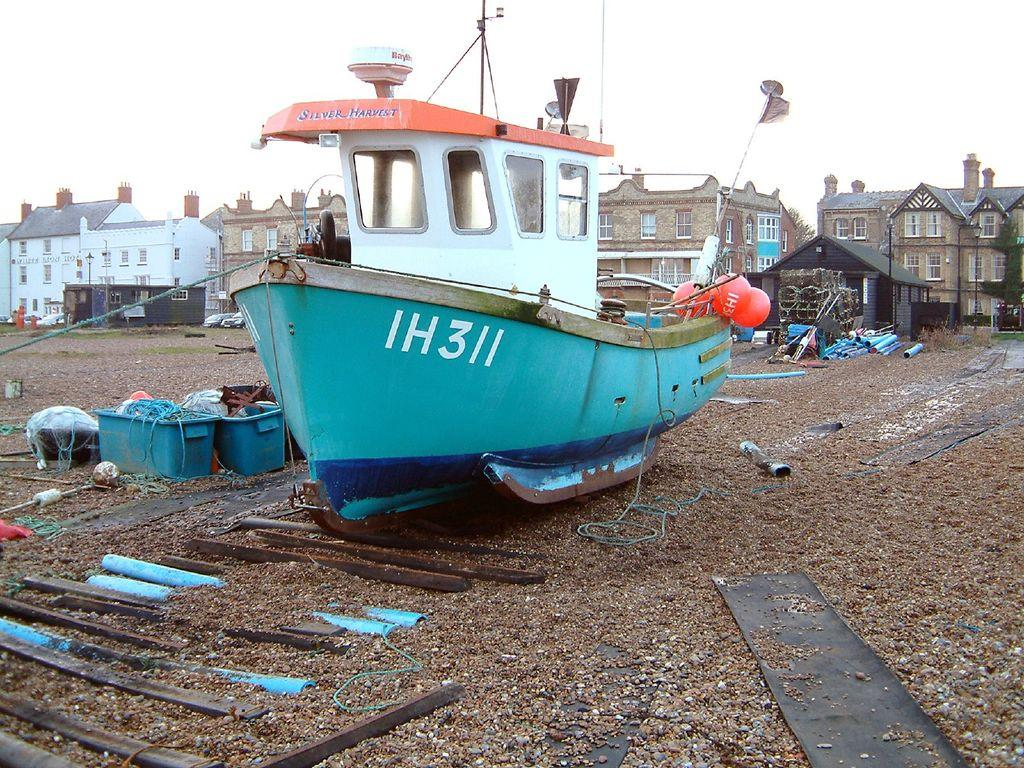What can be seen in the background of the image? In the background of the image, there are buildings, houses, and a sky visible. What is the flag attached to in the image? The flag is attached to rods in the image. What are the poles used for in the image? The poles are likely used to support the flag or other objects in the image. What is the boat situated on in the image? The boat is situated on the ground visible in the image. Can you describe any other objects present in the image? There are other objects present in the image, but their specific details are not mentioned in the provided facts. What type of turkey can be seen walking around in the image? There is no turkey present in the image; it features a boat, flag, buildings, houses, and other objects. What kind of pet is sitting on the boat in the image? There is no pet visible in the image; it only shows a boat, flag, buildings, houses, and other objects. 